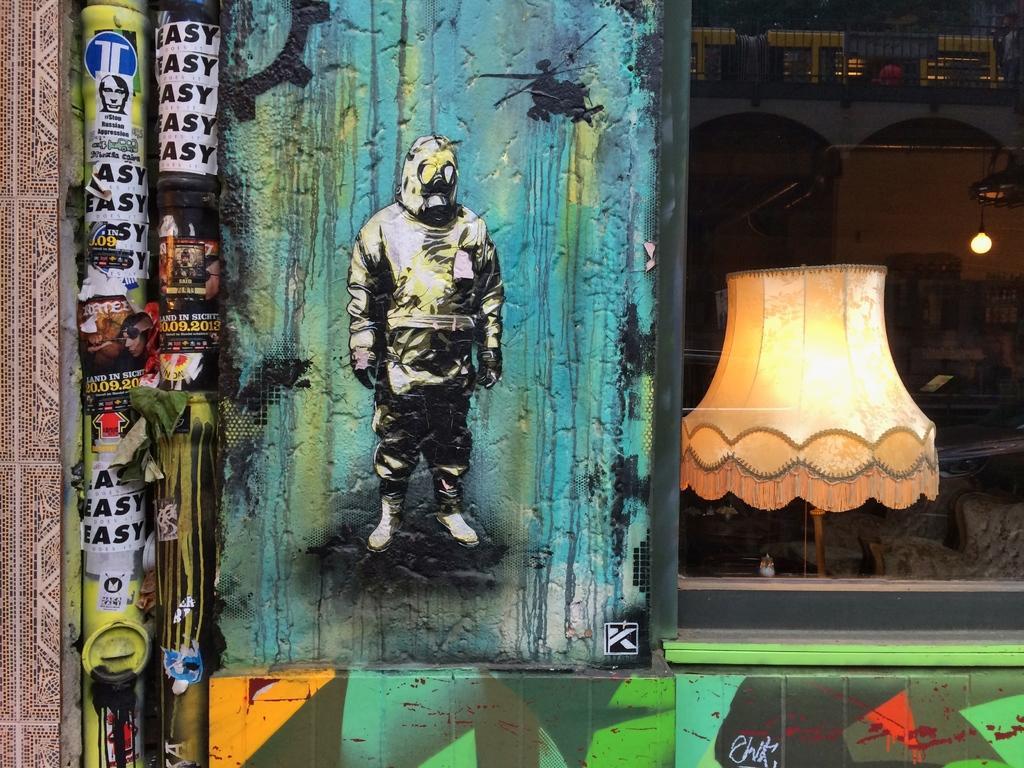Can you describe this image briefly? In this image in the front on the wall there is graffiti. On the right side there is a light lamp. In the background there is wall and there is a light hanging, and on the top there is fence which is black in colour. On the left side in the front there are pipes and there are posters on the pipe with some text written on it. 